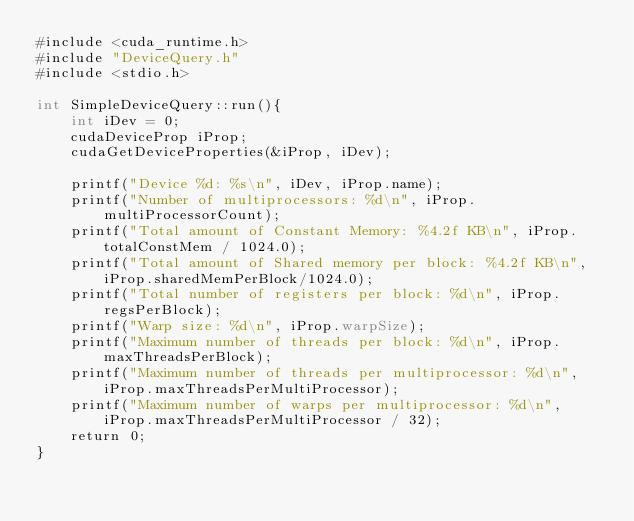Convert code to text. <code><loc_0><loc_0><loc_500><loc_500><_Cuda_>#include <cuda_runtime.h>
#include "DeviceQuery.h"
#include <stdio.h>

int SimpleDeviceQuery::run(){
    int iDev = 0;
    cudaDeviceProp iProp;
    cudaGetDeviceProperties(&iProp, iDev);

    printf("Device %d: %s\n", iDev, iProp.name);
    printf("Number of multiprocessors: %d\n", iProp.multiProcessorCount);
    printf("Total amount of Constant Memory: %4.2f KB\n", iProp.totalConstMem / 1024.0);
    printf("Total amount of Shared memory per block: %4.2f KB\n", iProp.sharedMemPerBlock/1024.0);
    printf("Total number of registers per block: %d\n", iProp.regsPerBlock);
    printf("Warp size: %d\n", iProp.warpSize);
    printf("Maximum number of threads per block: %d\n", iProp.maxThreadsPerBlock);
    printf("Maximum number of threads per multiprocessor: %d\n", iProp.maxThreadsPerMultiProcessor);
    printf("Maximum number of warps per multiprocessor: %d\n", iProp.maxThreadsPerMultiProcessor / 32);
    return 0;
}</code> 